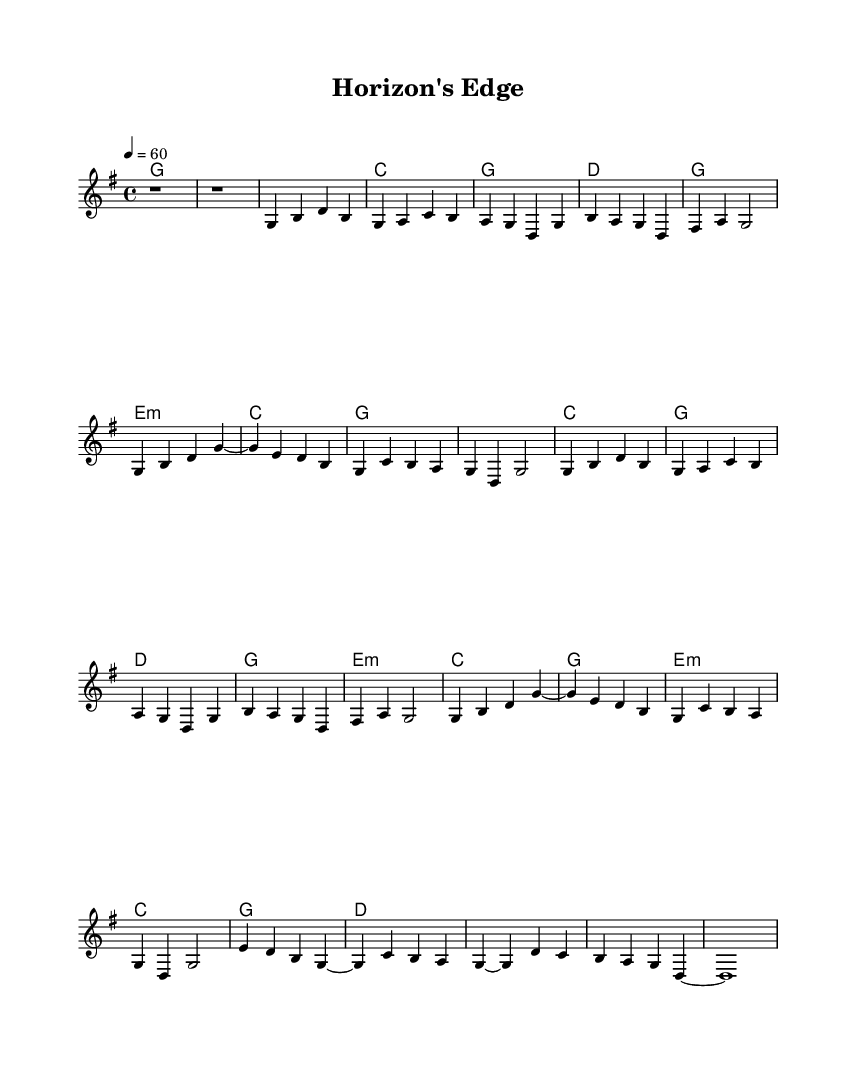What is the key signature of this music? The key signature is G major, which has one sharp (F#). This can be identified at the beginning of the staff, where the sharp is shown before the notes.
Answer: G major What is the time signature of this music? The time signature is 4/4, indicating four beats per measure with a quarter note receiving one beat. This can be seen at the start of the sheet music where the time signature is notated.
Answer: 4/4 What is the tempo marking of this piece? The tempo marking is quarter note equals 60 beats per minute. This is indicated at the beginning of the score where the tempo is written.
Answer: 60 How many verses does this piece have? The piece has two verses, which are labeled as Verse 1 and Verse 2 in the music. Counting these sections in the structure provides the total number of verses.
Answer: 2 What is the overall form of this piece? The overall form is Verse-Chorus structure, with verses followed by repeated choruses. This can be discerned by looking at the layout of the sections in the music.
Answer: Verse-Chorus What type of harmony is predominantly used in this ballad? The predominant harmony is diatonic chords typical of country music, such as G, C, D, and E minor. This can be seen in the chord changes under the melody throughout the piece.
Answer: Diatonic chords What is the character or mood conveyed by the music? The piece conveys a nostalgic and reflective mood typical of country ballads, as suggested by the slow tempo and lyrical melody line. This can be assessed through the overall structure and style of the music.
Answer: Nostalgic 